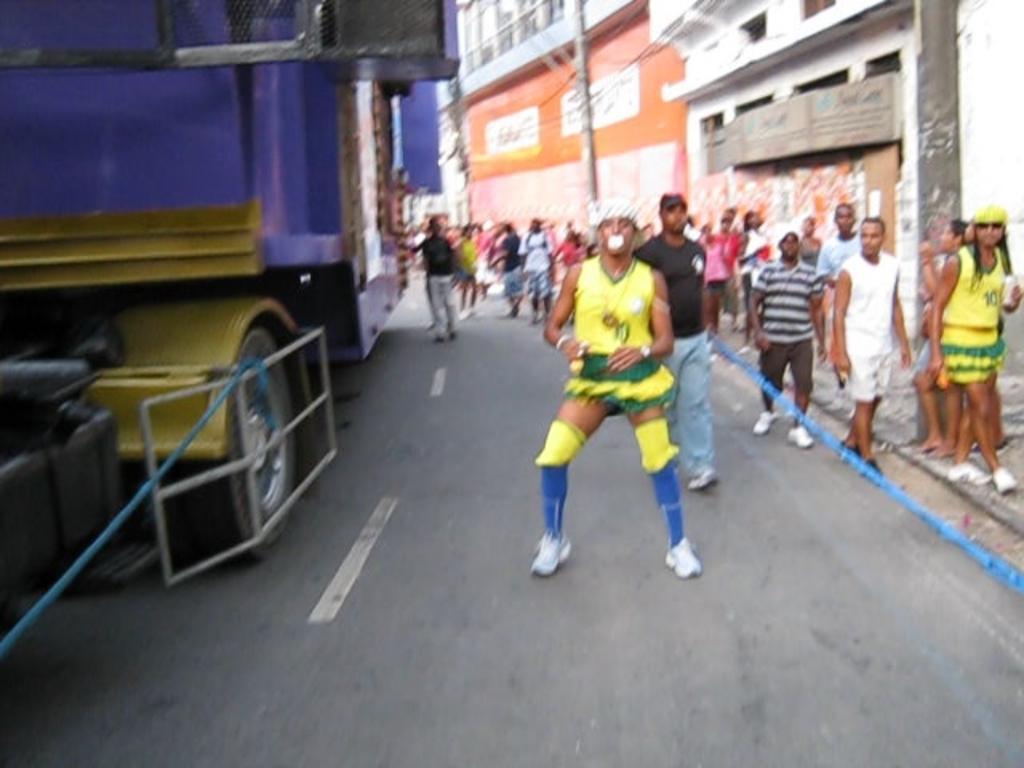Can you describe this image briefly? In this image we can see a road. On the road there is a vehicle. Also there are many people. On the right side there is a building. And there are tapes. 